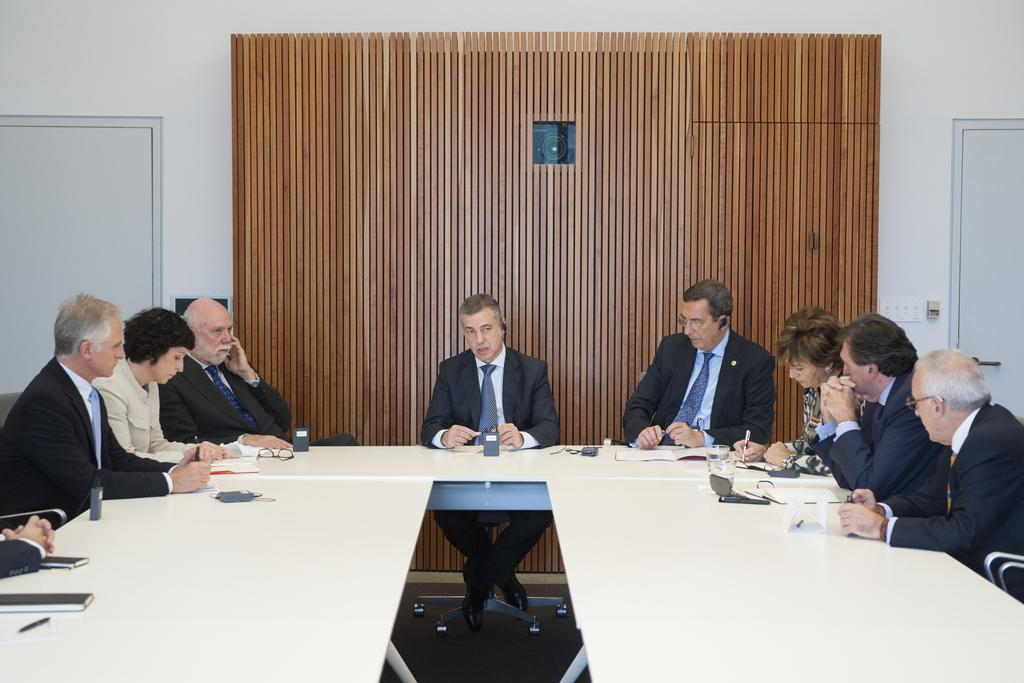Who or what can be seen in the image? There are people in the image. What are the people doing in the image? The people are sitting on chairs. What is in front of the chairs? There is a table in front of the chairs. Can you see a stream of water flowing near the people in the image? There is no stream of water visible in the image. What type of pig is sitting with the people at the table? There is no pig present in the image. 